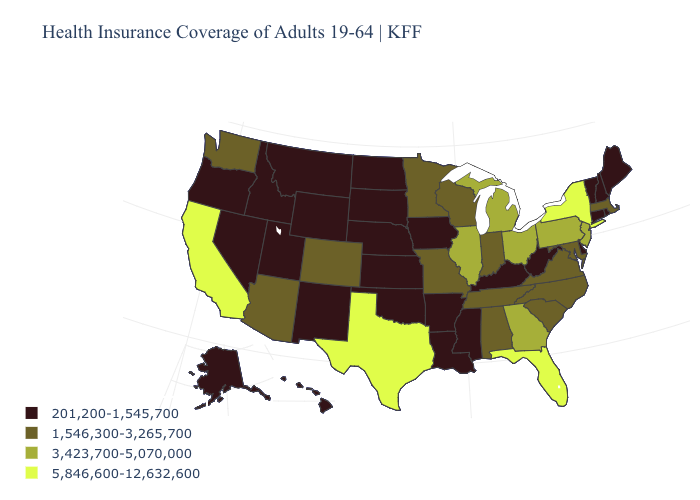Name the states that have a value in the range 1,546,300-3,265,700?
Be succinct. Alabama, Arizona, Colorado, Indiana, Maryland, Massachusetts, Minnesota, Missouri, North Carolina, South Carolina, Tennessee, Virginia, Washington, Wisconsin. What is the value of South Dakota?
Quick response, please. 201,200-1,545,700. Name the states that have a value in the range 3,423,700-5,070,000?
Concise answer only. Georgia, Illinois, Michigan, New Jersey, Ohio, Pennsylvania. Which states hav the highest value in the MidWest?
Quick response, please. Illinois, Michigan, Ohio. What is the value of Vermont?
Be succinct. 201,200-1,545,700. Name the states that have a value in the range 201,200-1,545,700?
Give a very brief answer. Alaska, Arkansas, Connecticut, Delaware, Hawaii, Idaho, Iowa, Kansas, Kentucky, Louisiana, Maine, Mississippi, Montana, Nebraska, Nevada, New Hampshire, New Mexico, North Dakota, Oklahoma, Oregon, Rhode Island, South Dakota, Utah, Vermont, West Virginia, Wyoming. What is the lowest value in the South?
Short answer required. 201,200-1,545,700. Name the states that have a value in the range 1,546,300-3,265,700?
Write a very short answer. Alabama, Arizona, Colorado, Indiana, Maryland, Massachusetts, Minnesota, Missouri, North Carolina, South Carolina, Tennessee, Virginia, Washington, Wisconsin. Among the states that border Washington , which have the highest value?
Keep it brief. Idaho, Oregon. Is the legend a continuous bar?
Write a very short answer. No. What is the lowest value in states that border Tennessee?
Answer briefly. 201,200-1,545,700. What is the value of Maine?
Give a very brief answer. 201,200-1,545,700. Does Massachusetts have a lower value than California?
Answer briefly. Yes. Among the states that border Tennessee , which have the lowest value?
Be succinct. Arkansas, Kentucky, Mississippi. What is the lowest value in states that border Georgia?
Quick response, please. 1,546,300-3,265,700. 